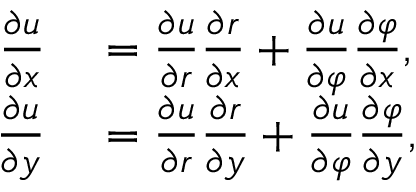<formula> <loc_0><loc_0><loc_500><loc_500>\begin{array} { r l } { { \frac { \partial u } { \partial x } } } & = { \frac { \partial u } { \partial r } } { \frac { \partial r } { \partial x } } + { \frac { \partial u } { \partial \varphi } } { \frac { \partial \varphi } { \partial x } } , } \\ { { \frac { \partial u } { \partial y } } } & = { \frac { \partial u } { \partial r } } { \frac { \partial r } { \partial y } } + { \frac { \partial u } { \partial \varphi } } { \frac { \partial \varphi } { \partial y } } , } \end{array}</formula> 